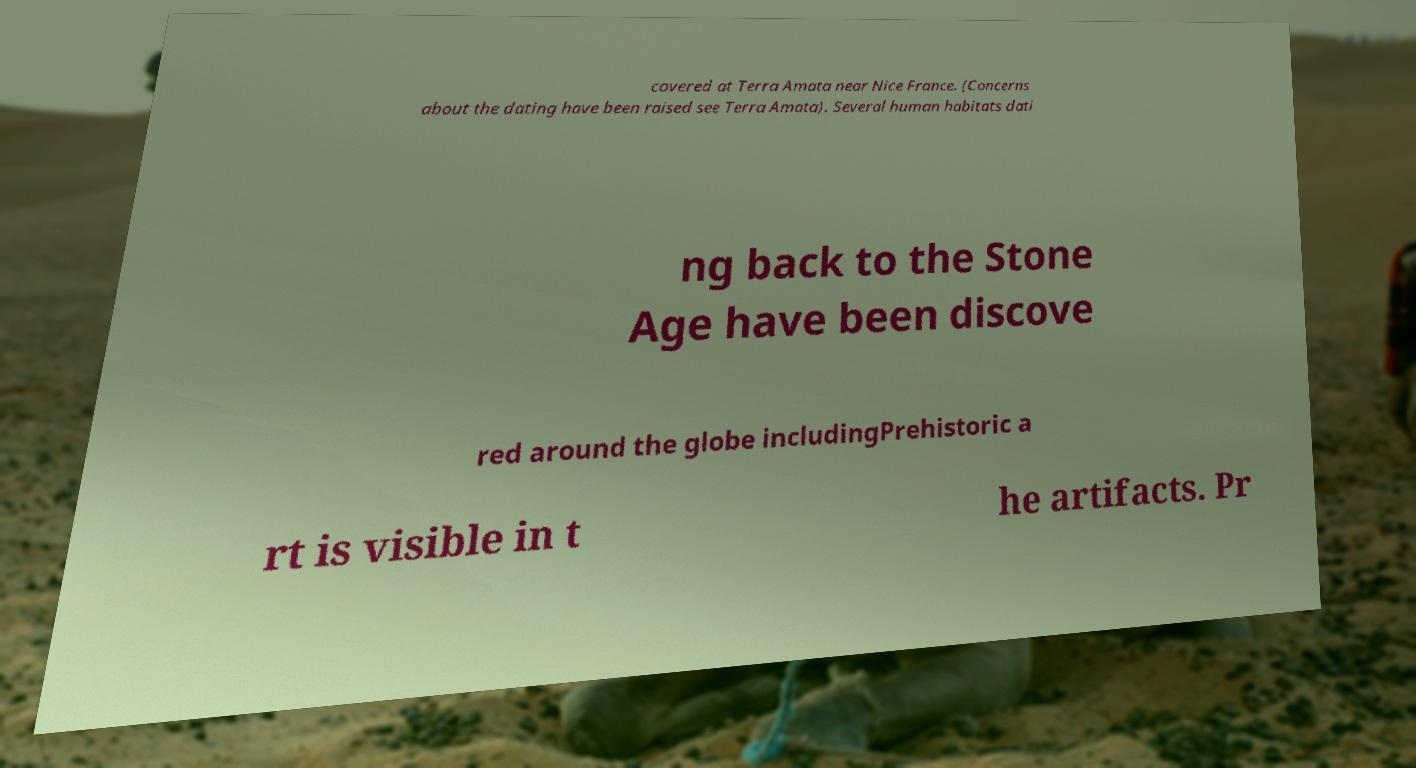I need the written content from this picture converted into text. Can you do that? covered at Terra Amata near Nice France. (Concerns about the dating have been raised see Terra Amata). Several human habitats dati ng back to the Stone Age have been discove red around the globe includingPrehistoric a rt is visible in t he artifacts. Pr 